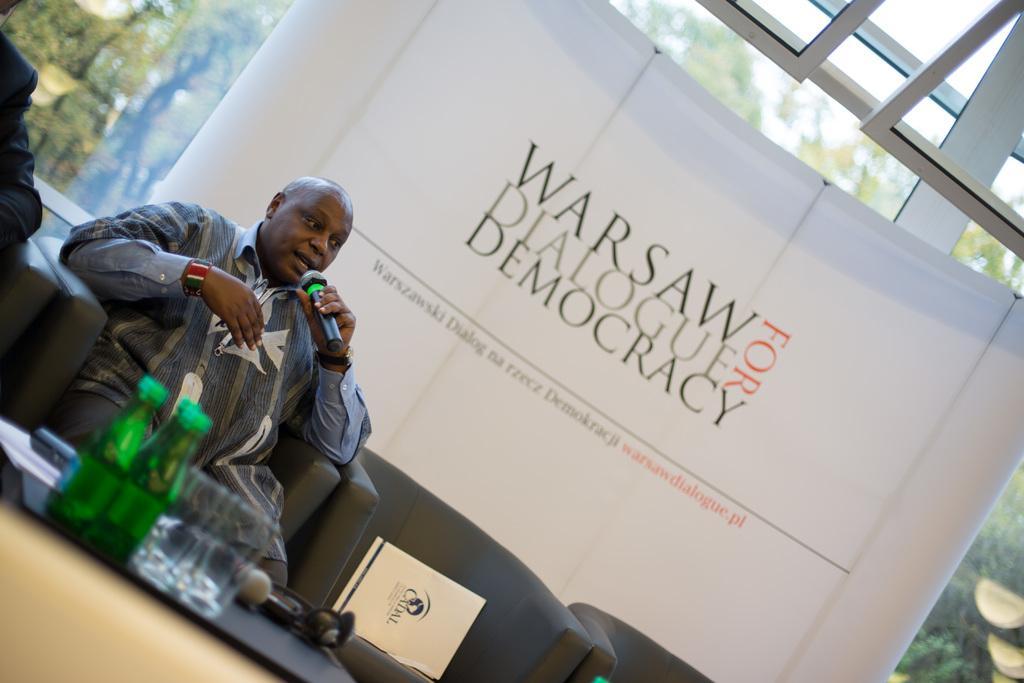Can you describe this image briefly? As we can see in the image there are sofas, tables and two persons sitting on sofas. On tables there are bottles and glasses. There is a banner and in the background there are trees. 